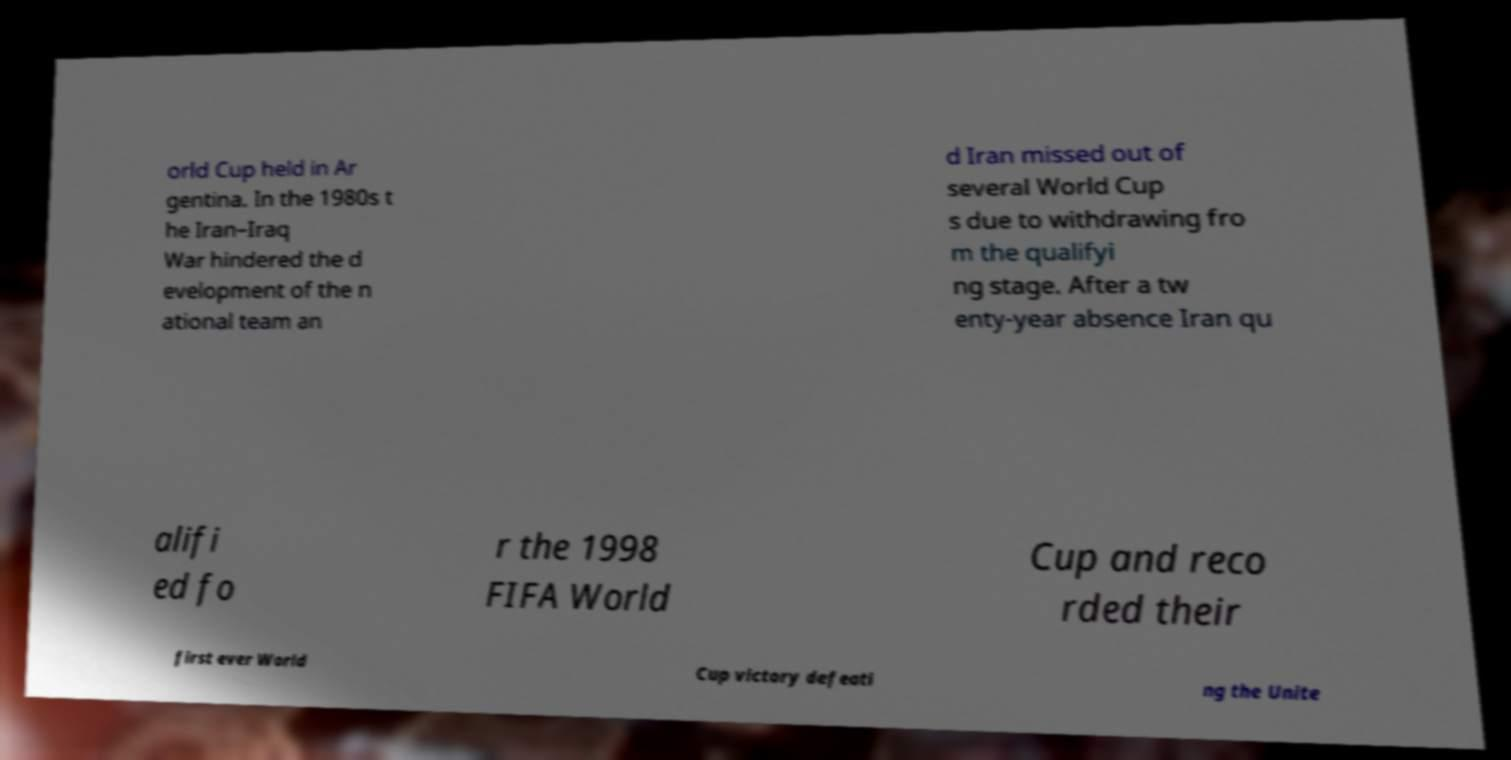Please read and relay the text visible in this image. What does it say? orld Cup held in Ar gentina. In the 1980s t he Iran–Iraq War hindered the d evelopment of the n ational team an d Iran missed out of several World Cup s due to withdrawing fro m the qualifyi ng stage. After a tw enty-year absence Iran qu alifi ed fo r the 1998 FIFA World Cup and reco rded their first ever World Cup victory defeati ng the Unite 